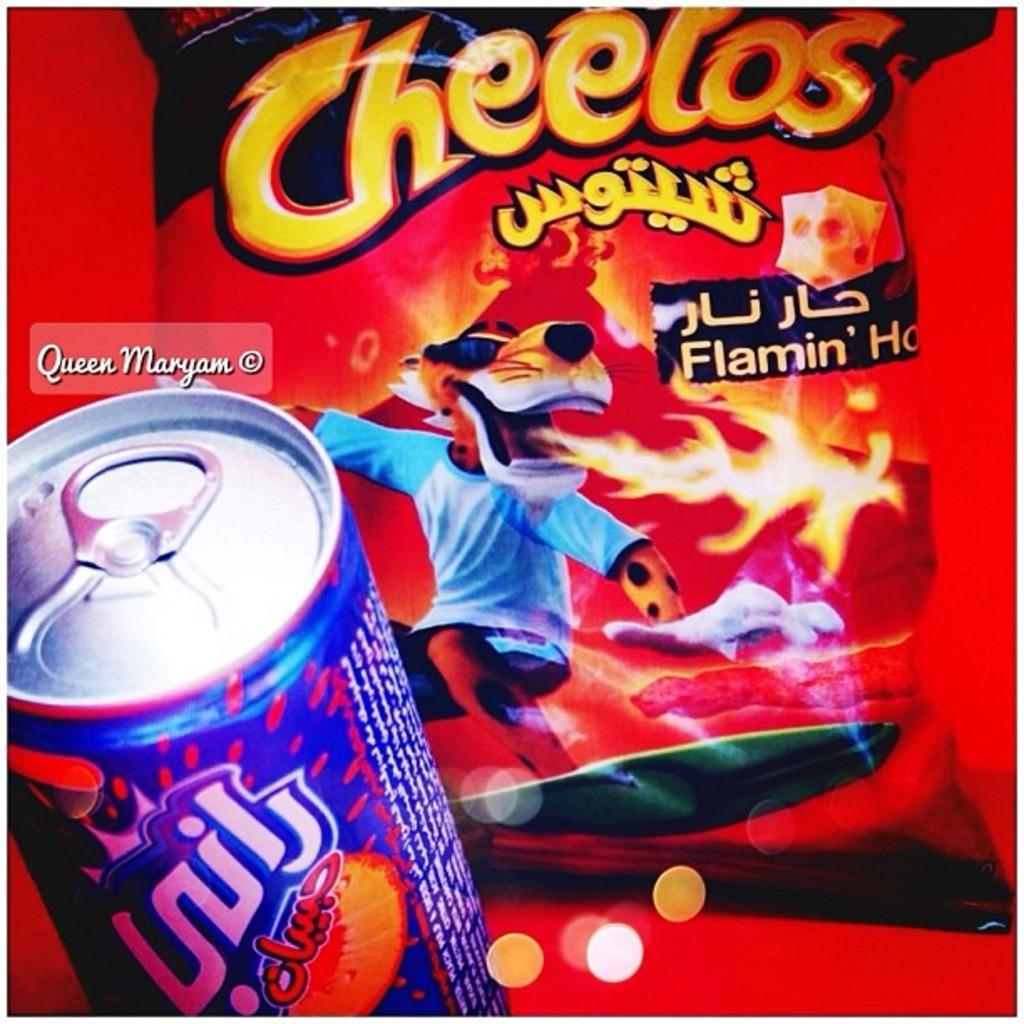What brand of chip snack is shown?
Your response must be concise. Cheetos. What flavor of cheetos?
Offer a very short reply. Flamin' hot. 